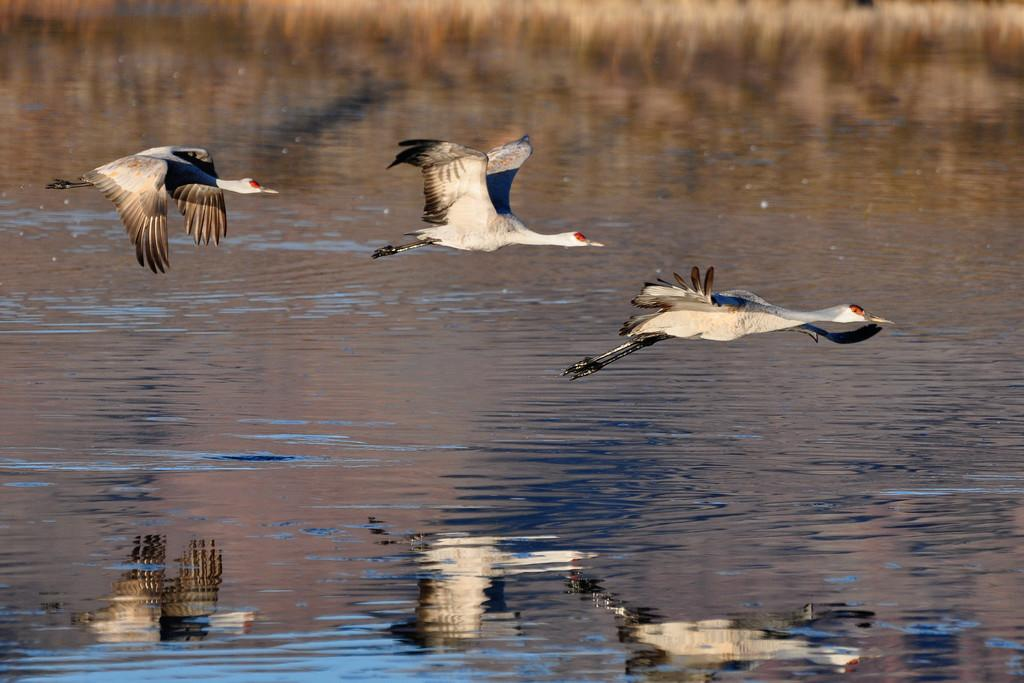What type of animals can be seen in the image? There are birds in the image. What are the birds doing in the image? The birds are flying in the image. Where are the birds located in the image? The birds are in the center of the image. What can be seen in the background of the image? There is water visible in the image. What type of pancake is being sold at the shop in the image? There is no shop or pancake present in the image; it features birds flying over water. 